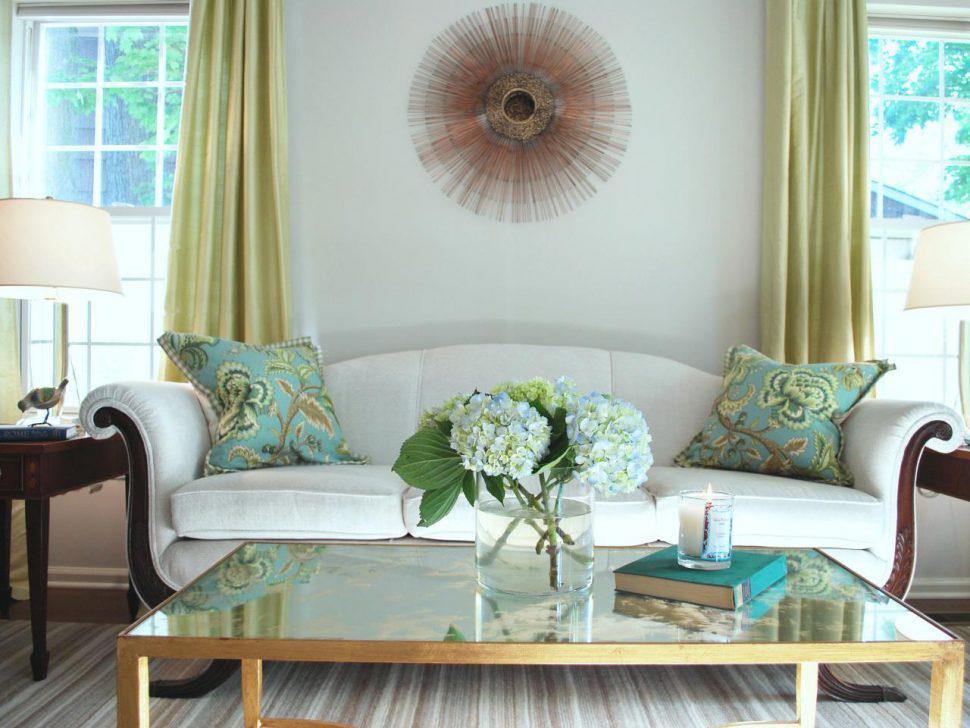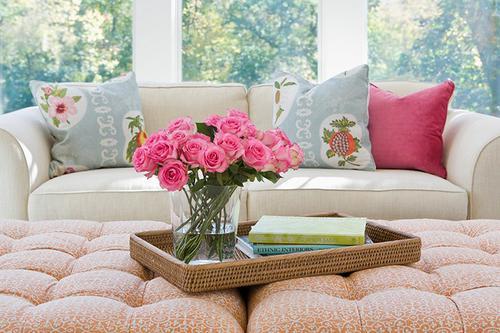The first image is the image on the left, the second image is the image on the right. Given the left and right images, does the statement "there are white columns behind a sofa" hold true? Answer yes or no. Yes. The first image is the image on the left, the second image is the image on the right. Evaluate the accuracy of this statement regarding the images: "The pillows in the left image match the sofa.". Is it true? Answer yes or no. No. 